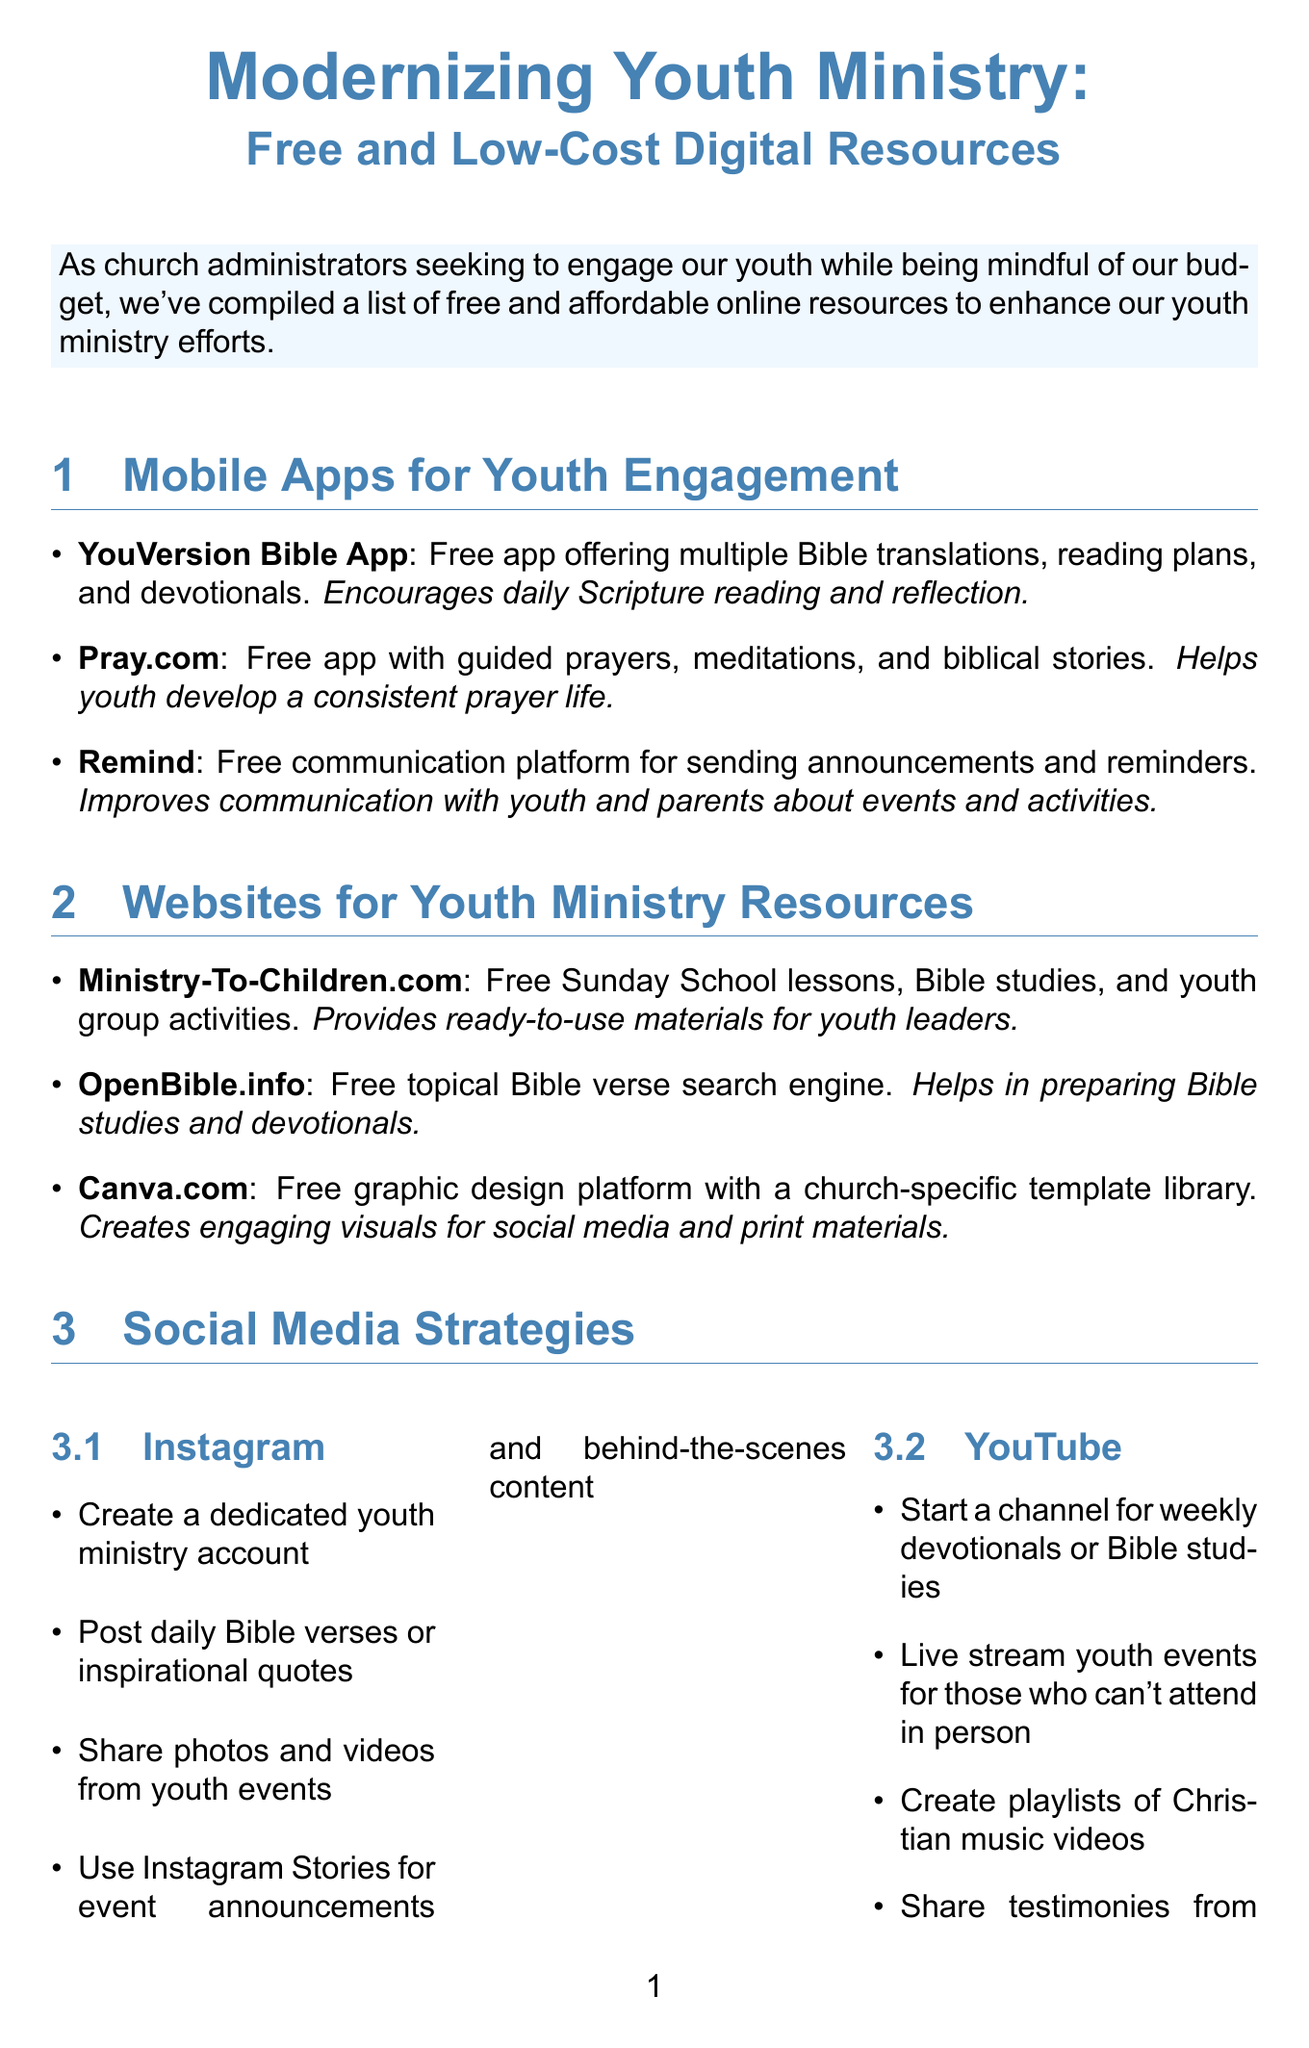What is the title of the newsletter? The title of the newsletter is provided at the beginning, summarizing its focus on modernizing youth ministry with resources.
Answer: Modernizing Youth Ministry: Free and Low-Cost Digital Resources How many mobile apps are listed for youth engagement? The document lists three specific mobile apps under the section for youth engagement.
Answer: 3 What is the main benefit of using the YouVersion Bible App? The benefit of this app is mentioned alongside its description, highlighting its purpose.
Answer: Encourages daily Scripture reading and reflection Which social media platform is suggested for live streaming youth events? The document specifies YouTube as the platform for live streaming, along with its strategies.
Answer: YouTube What is the free plan limit for MailChimp? The limit for the free plan is specifically stated in
the low-cost tools section of the document.
Answer: Up to 2,000 contacts What type of document is this? The content and formatting of the document suggest it is designed to inform and provide resources, typical of a newsletter format.
Answer: Newsletter Which online tool is associated with organizing youth ministry events? The description of Trello indicates its function related to organizing tasks for youth ministry events.
Answer: Trello What strategy is suggested for Instagram? The document provides several strategies, asking for one related to the engagement of youth on this platform.
Answer: Create a dedicated youth ministry account 